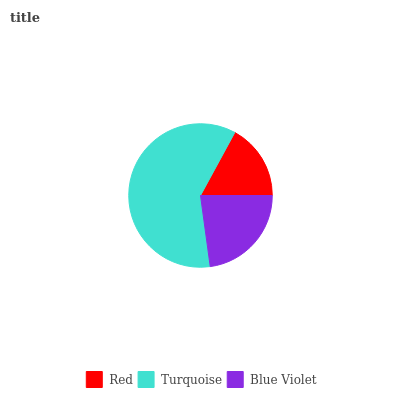Is Red the minimum?
Answer yes or no. Yes. Is Turquoise the maximum?
Answer yes or no. Yes. Is Blue Violet the minimum?
Answer yes or no. No. Is Blue Violet the maximum?
Answer yes or no. No. Is Turquoise greater than Blue Violet?
Answer yes or no. Yes. Is Blue Violet less than Turquoise?
Answer yes or no. Yes. Is Blue Violet greater than Turquoise?
Answer yes or no. No. Is Turquoise less than Blue Violet?
Answer yes or no. No. Is Blue Violet the high median?
Answer yes or no. Yes. Is Blue Violet the low median?
Answer yes or no. Yes. Is Red the high median?
Answer yes or no. No. Is Red the low median?
Answer yes or no. No. 